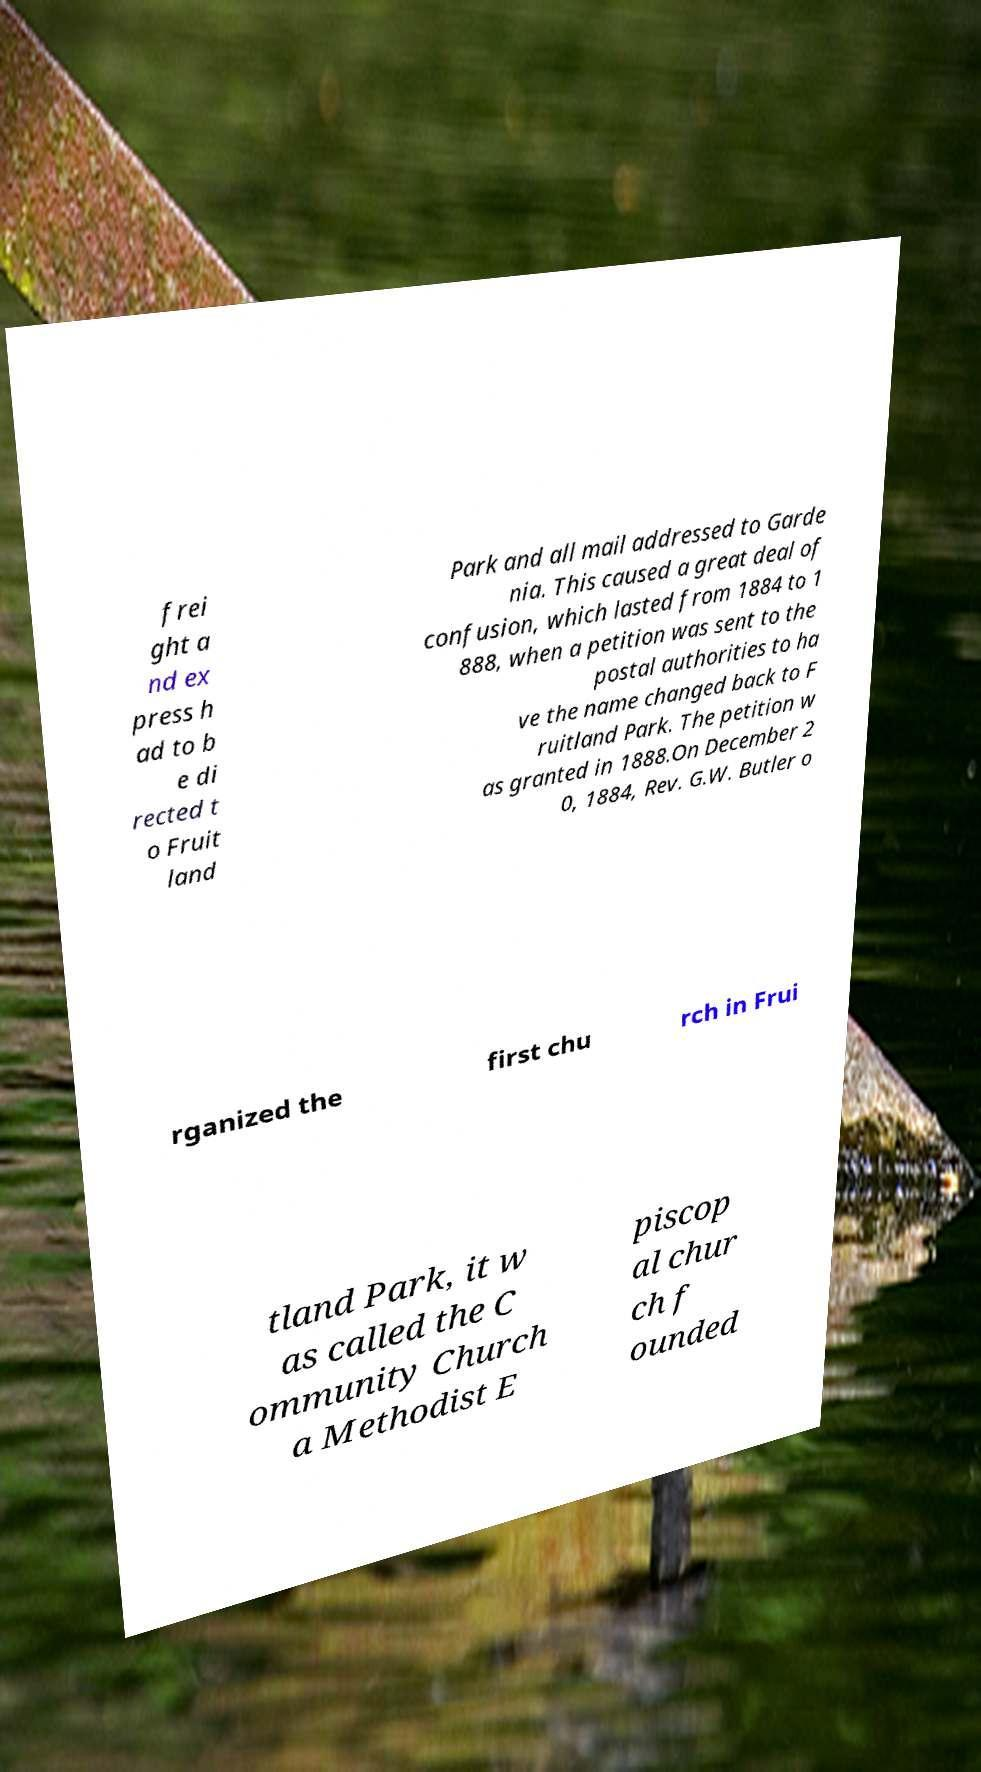Please read and relay the text visible in this image. What does it say? frei ght a nd ex press h ad to b e di rected t o Fruit land Park and all mail addressed to Garde nia. This caused a great deal of confusion, which lasted from 1884 to 1 888, when a petition was sent to the postal authorities to ha ve the name changed back to F ruitland Park. The petition w as granted in 1888.On December 2 0, 1884, Rev. G.W. Butler o rganized the first chu rch in Frui tland Park, it w as called the C ommunity Church a Methodist E piscop al chur ch f ounded 